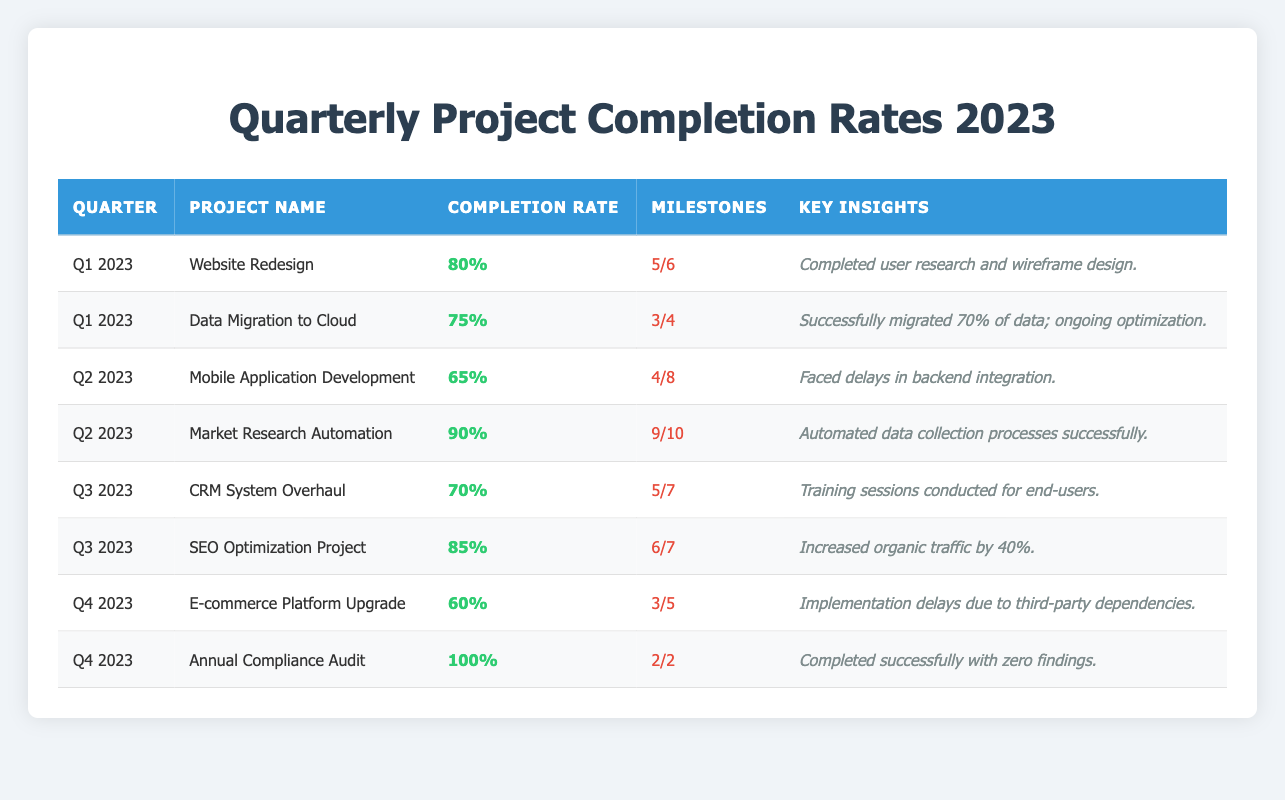What was the completion rate for the 'SEO Optimization Project'? The table lists the 'SEO Optimization Project' under Q3 2023 with a completion rate of 85%.
Answer: 85% Which project had the highest completion rate? Upon reviewing the table, the 'Annual Compliance Audit' in Q4 2023 has the highest completion rate of 100%.
Answer: Annual Compliance Audit What is the total number of milestones achieved across all projects in Q2 2023? From the table for Q2 2023, 'Mobile Application Development' has 4 milestones achieved, and 'Market Research Automation' has 9; thus, total milestones achieved is 4 + 9 = 13.
Answer: 13 Did the 'E-commerce Platform Upgrade' achieve all its milestones? Looking at the data for the 'E-commerce Platform Upgrade' in Q4 2023, it achieved 3 out of 5 milestones, which means it did not achieve all milestones.
Answer: No What was the overall average completion rate for the projects in Q1 2023? Q1 2023 projects include two: 'Website Redesign' at 80% and 'Data Migration to Cloud' at 75%. The average is (80 + 75)/2 = 155/2 = 77.5%.
Answer: 77.5% How many projects had completion rates below 70%? The table shows that 'Mobile Application Development' at 65% and 'E-commerce Platform Upgrade' at 60% are the only projects below 70%, resulting in a total of 2 projects.
Answer: 2 What insights were gained from the 'Market Research Automation' project? Referring to the table, the key insight for 'Market Research Automation' is that "Automated data collection processes successfully" was achieved.
Answer: Automated data collection processes successfully Which quarter had the highest total milestones planned across all projects, and what was the total? Q2 2023 has 'Mobile Application Development' with 8 total milestones and 'Market Research Automation' with 10, which total 8 + 10 = 18 milestones; thus, it is the highest.
Answer: Q2 2023, 18 